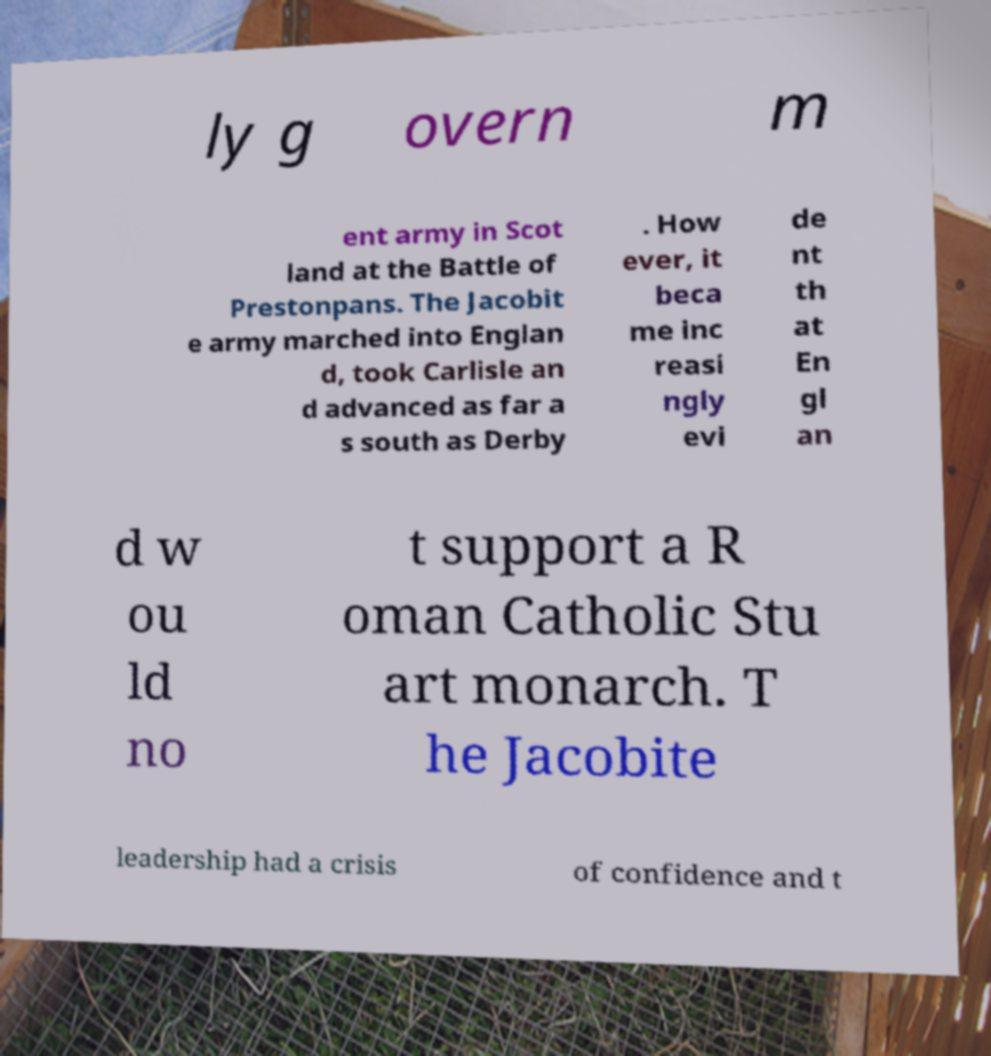Please read and relay the text visible in this image. What does it say? ly g overn m ent army in Scot land at the Battle of Prestonpans. The Jacobit e army marched into Englan d, took Carlisle an d advanced as far a s south as Derby . How ever, it beca me inc reasi ngly evi de nt th at En gl an d w ou ld no t support a R oman Catholic Stu art monarch. T he Jacobite leadership had a crisis of confidence and t 